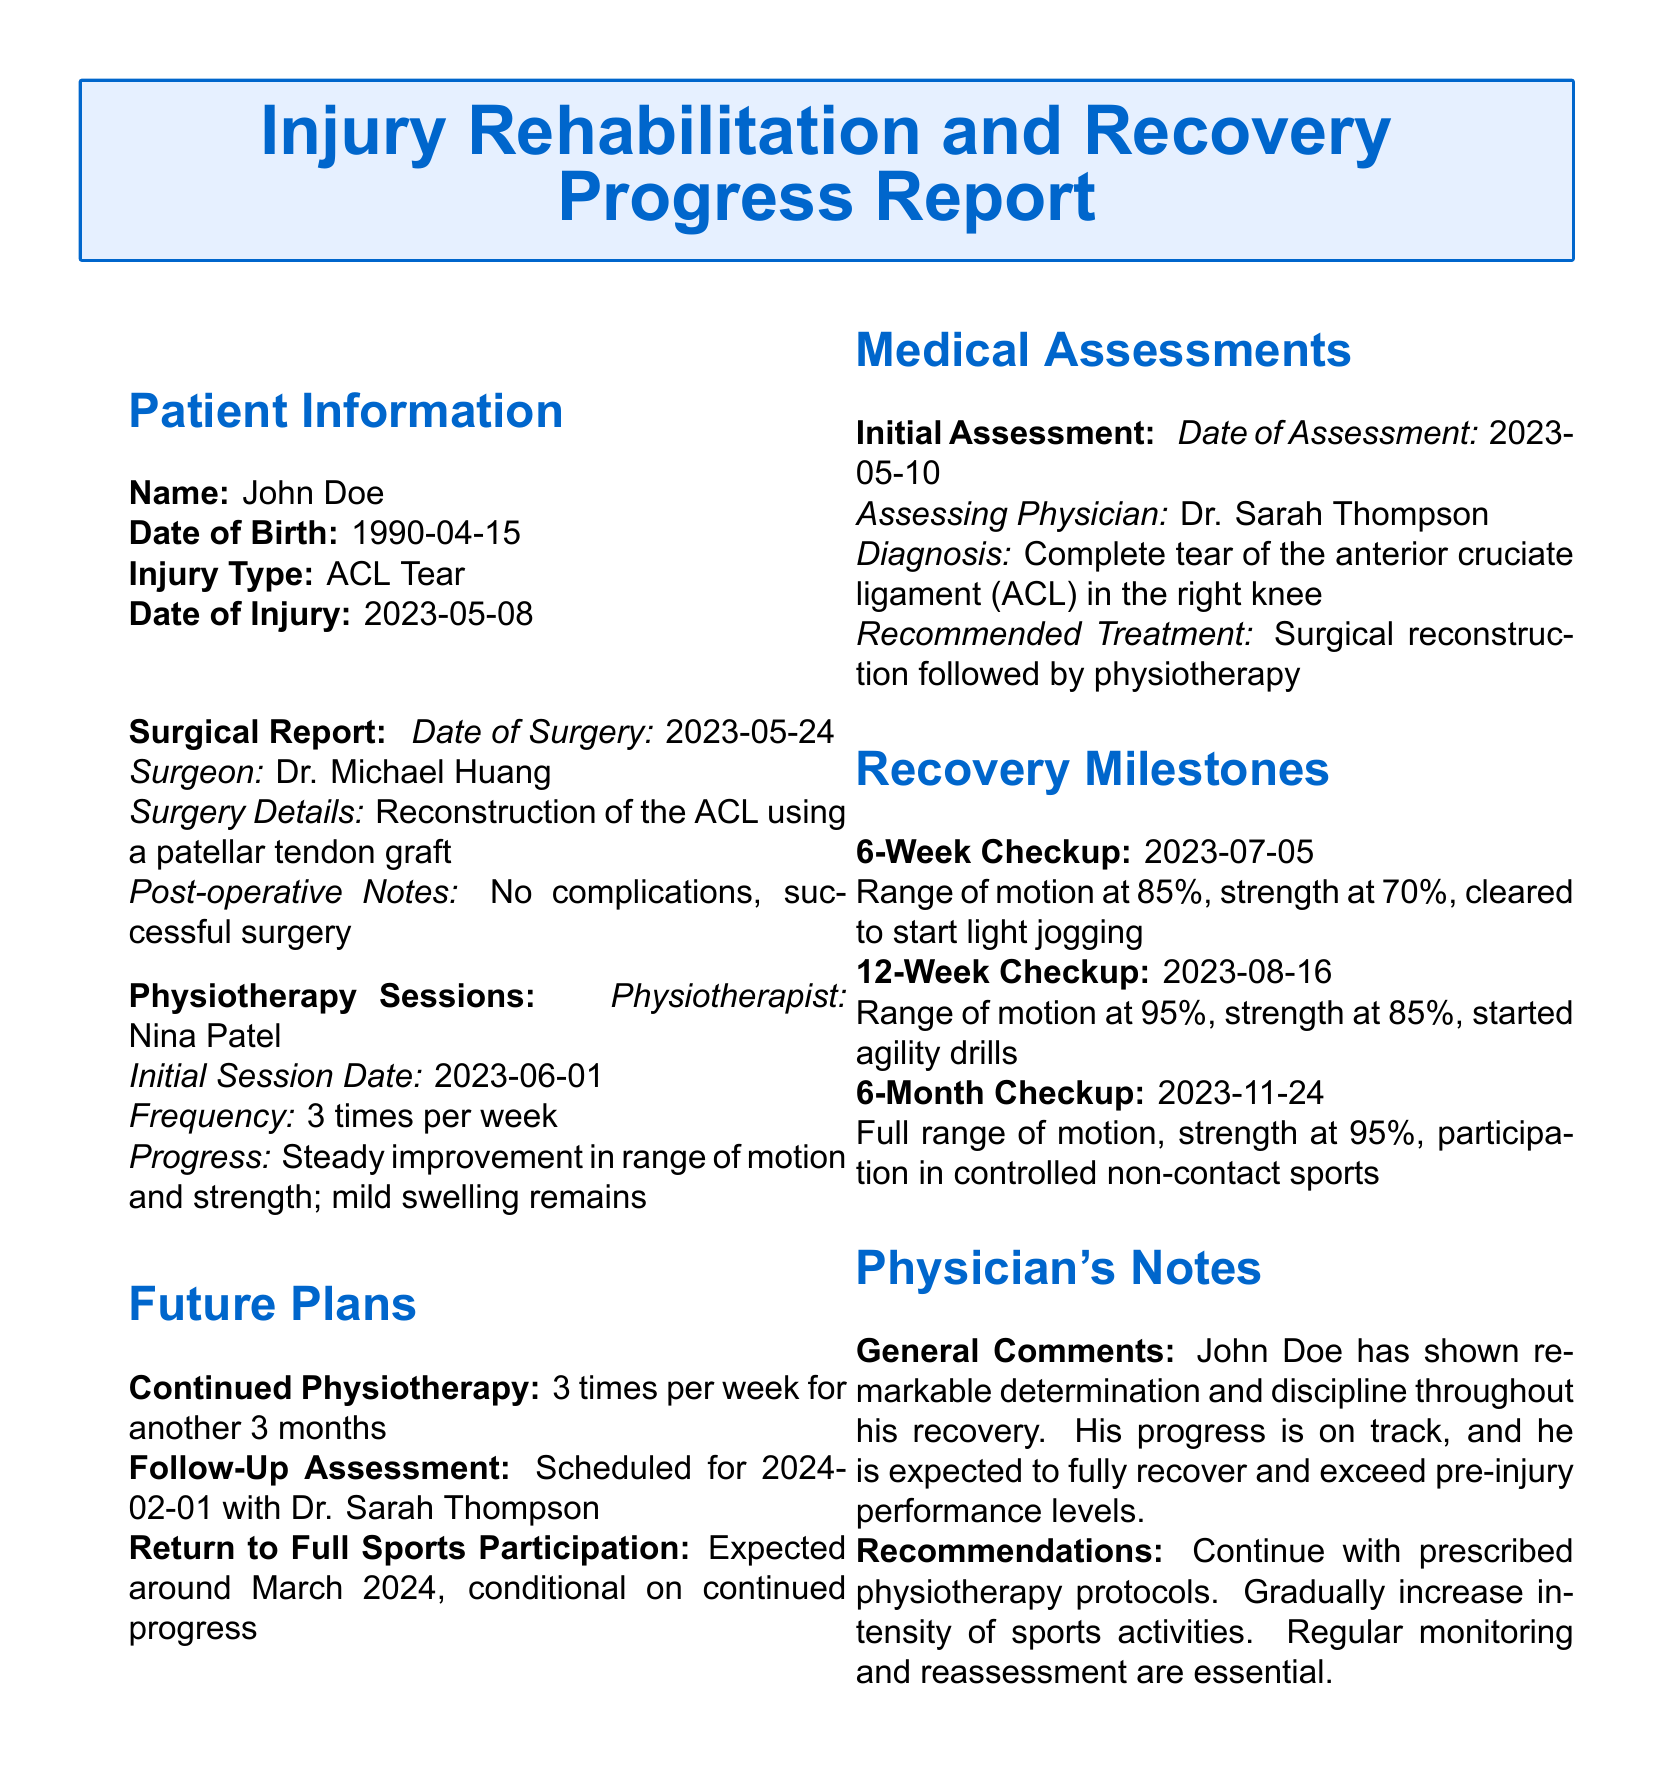what is the patient's name? The patient's name is specified in the document under Patient Information.
Answer: John Doe what is the type of injury? The type of injury is mentioned in the Patient Information section.
Answer: ACL Tear when was the date of injury? The date of injury is listed in the Patient Information section.
Answer: 2023-05-08 who performed the surgery? The surgeon's name is provided in the Surgical Report section.
Answer: Dr. Michael Huang what was the range of motion at the 12-week checkup? The range of motion at the 12-week checkup is stated in the Recovery Milestones section.
Answer: 95% how often will physiotherapy sessions continue after the 6-month checkup? The frequency of continued physiotherapy sessions is mentioned in the Future Plans section.
Answer: 3 times per week what is the expected return to full sports participation date? The expected date for return to full sports is found in the Future Plans section.
Answer: March 2024 who is the assessing physician for the initial assessment? The assessing physician's name is noted in the Medical Assessments section.
Answer: Dr. Sarah Thompson what was the strength percentage at the 6-week checkup? The strength percentage at the 6-week checkup is detailed in the Recovery Milestones section.
Answer: 70% 